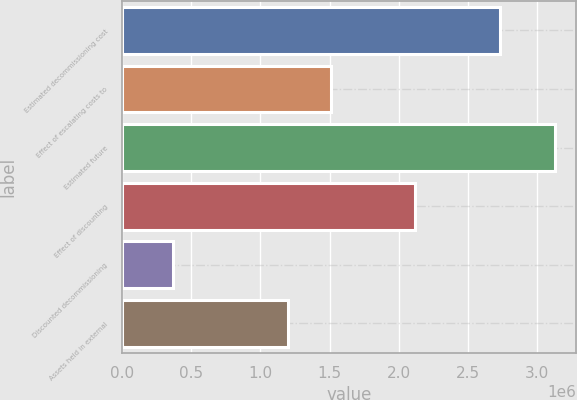Convert chart. <chart><loc_0><loc_0><loc_500><loc_500><bar_chart><fcel>Estimated decommissioning cost<fcel>Effect of escalating costs to<fcel>Estimated future<fcel>Effect of discounting<fcel>Discounted decommissioning<fcel>Assets held in external<nl><fcel>2.73371e+06<fcel>1.50729e+06<fcel>3.12683e+06<fcel>2.1205e+06<fcel>367387<fcel>1.20069e+06<nl></chart> 